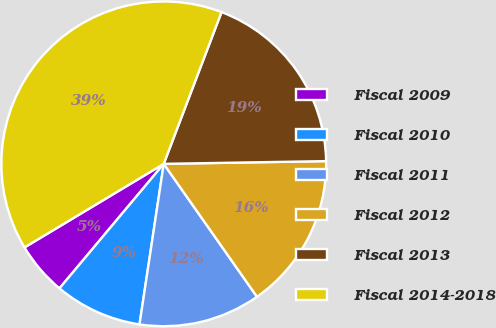Convert chart. <chart><loc_0><loc_0><loc_500><loc_500><pie_chart><fcel>Fiscal 2009<fcel>Fiscal 2010<fcel>Fiscal 2011<fcel>Fiscal 2012<fcel>Fiscal 2013<fcel>Fiscal 2014-2018<nl><fcel>5.3%<fcel>8.71%<fcel>12.12%<fcel>15.53%<fcel>18.94%<fcel>39.39%<nl></chart> 